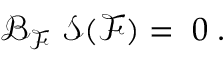<formula> <loc_0><loc_0><loc_500><loc_500>\mathcal { B } _ { \mathcal { F } } \ \mathcal { S ( F ) = } \, 0 \, .</formula> 